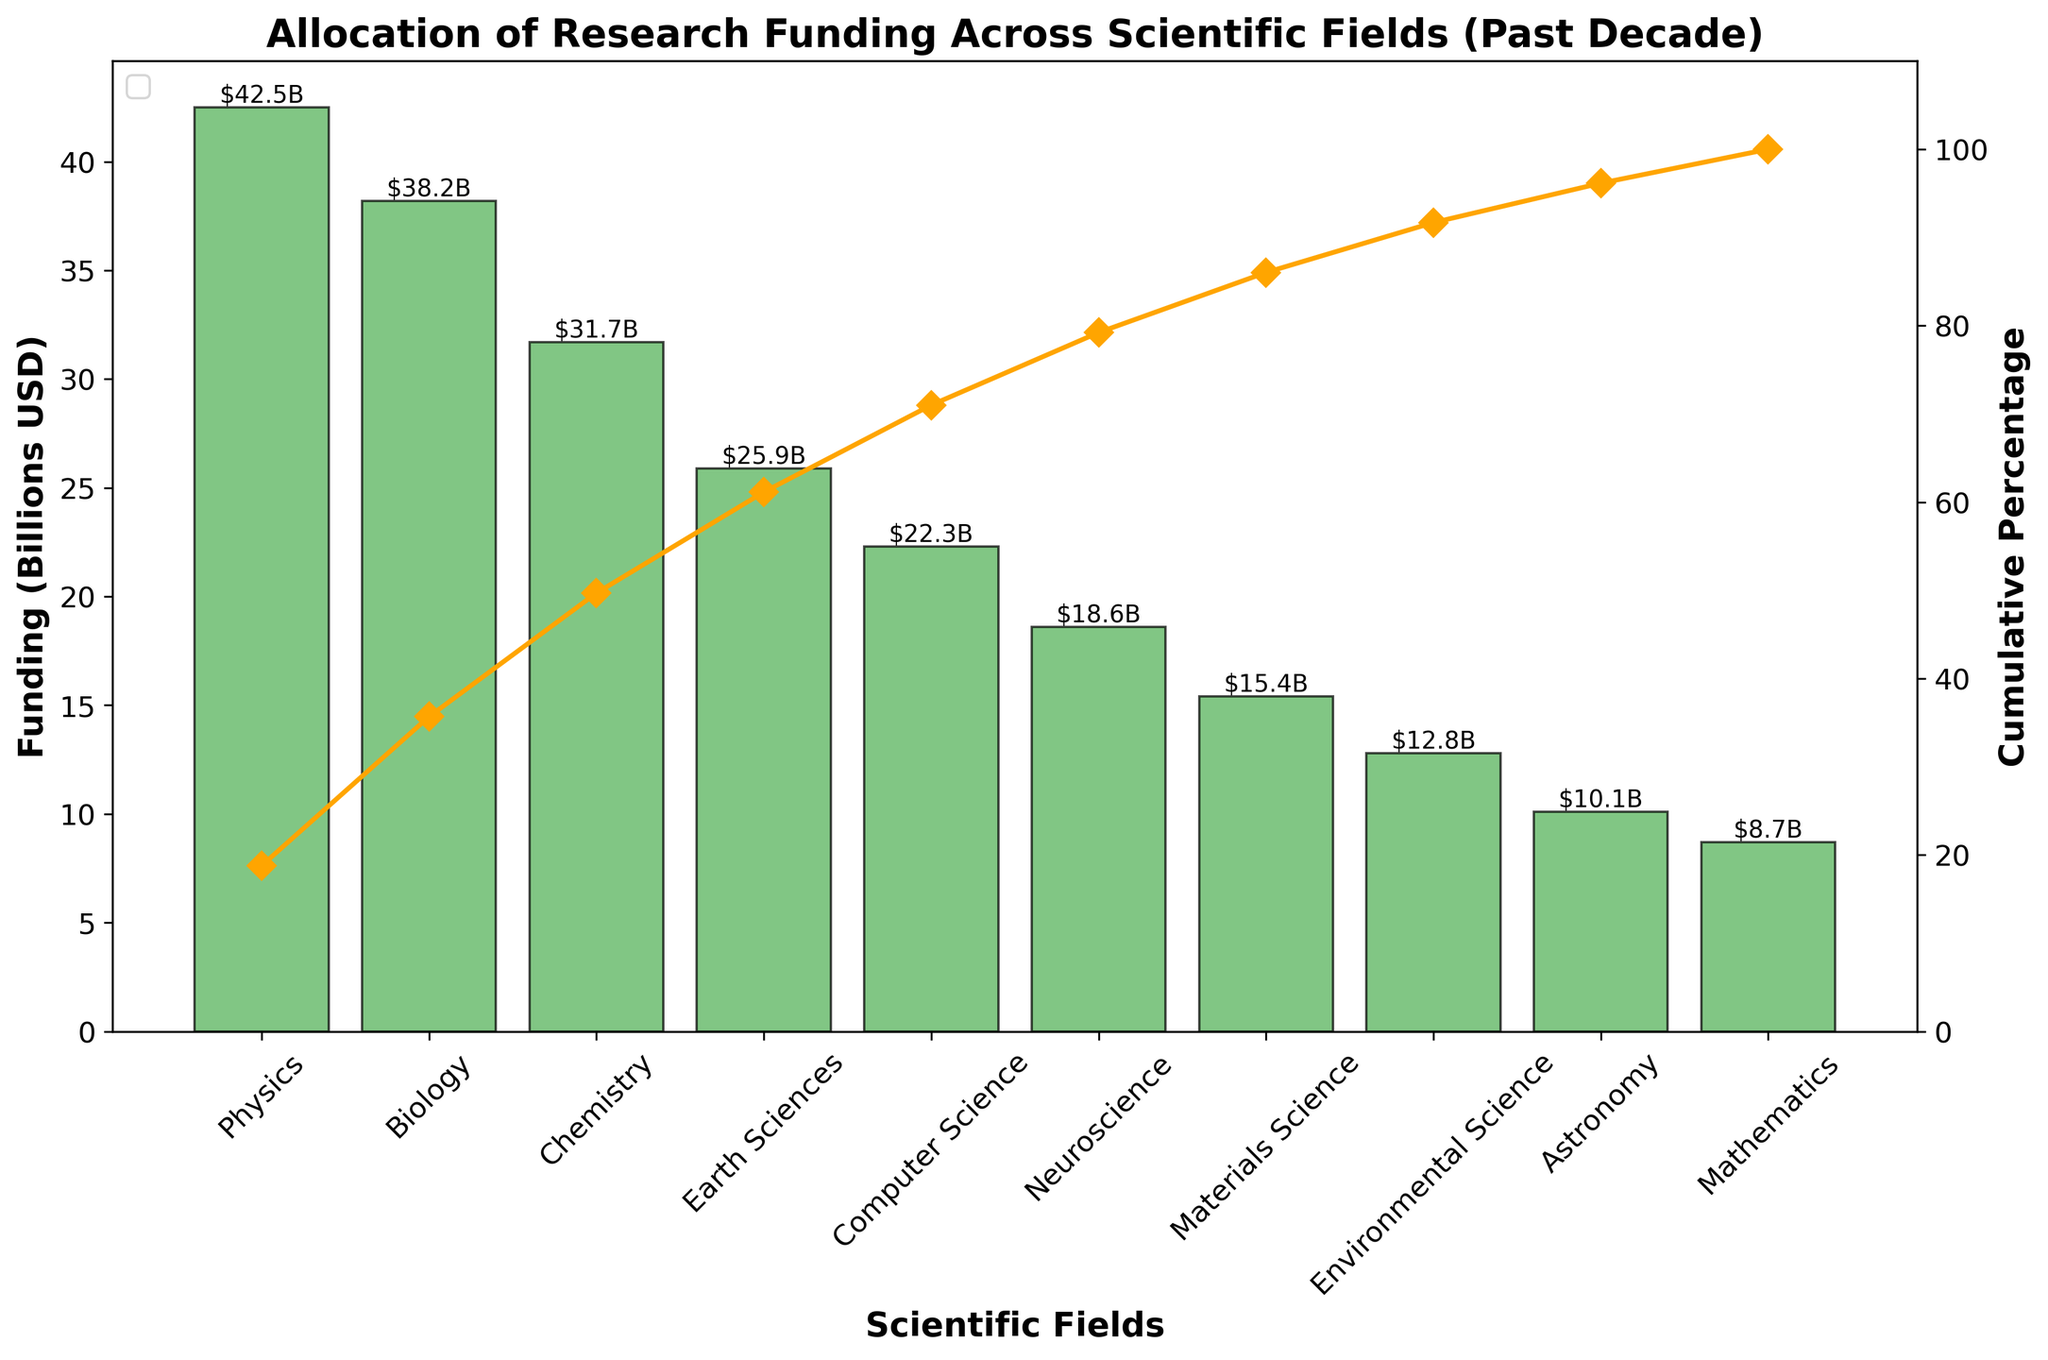What is the title of the figure? The title of the figure is generally placed at the top of the chart and it describes the overall content. According to the details, we can infer the title.
Answer: Allocation of Research Funding Across Scientific Fields (Past Decade) How many scientific fields are analyzed in the figure? The number of scientific fields can be determined by counting the bars in the bar plot.
Answer: 10 Which scientific field received the highest amount of funding? The bar with the greatest height represents the scientific field with the highest funding.
Answer: Physics What is the cumulative percentage for the field of Biology? The cumulative percentage for Biology can be read from the point on the secondary y-axis corresponding to Biology on the x-axis.
Answer: 48.5% What is the funding amount for Mathematics? The height of the bar corresponding to Mathematics indicates its funding amount.
Answer: 8.7 Billion USD Which fields combined make up 80% of the total funding? To find this, refer to the cumulative percentage line. The fields contributing to 80% can be found by moving along the line until reaching 80%.
Answer: Physics, Biology, Chemistry, and Earth Sciences How much more funding did Physics receive compared to Environmental Science? Find the heights of the bars for both Physics and Environmental Science and calculate their difference. Physics: 42.5 Billion USD, Environmental Science: 12.8 Billion USD. Hence, 42.5 - 12.8 = 29.7 Billion USD.
Answer: 29.7 Billion USD What percentage of the total funding does Computer Science account for? The percentage can be calculated by dividing the funding amount for Computer Science by the total funding and multiplying by 100. Total funding is the sum of all individual funding amounts. Total: 225.2 Billion USD, Computer Science: 22.3 Billion USD. Hence, (22.3 / 225.2) * 100 ≈ 9.9%.
Answer: 9.9% Which field contributes more to the total funding, Astronomy or Materials Science, and by how much? Compare the heights of the bars for Astronomy and Materials Science to determine which one is higher and calculate their difference. Materials Science: 15.4 Billion USD, Astronomy: 10.1 Billion USD. Hence, 15.4 - 10.1 = 5.3 Billion USD.
Answer: Materials Science by 5.3 Billion USD What is the average funding for the fields represented in the figure? Sum all the funding amounts and divide by the number of fields. Sum: 42.5 + 38.2 + 31.7 + 25.9 + 22.3 + 18.6 + 15.4 + 12.8 + 10.1 + 8.7 = 225.2 Billion USD. Average: 225.2 / 10 = 22.52 Billion USD.
Answer: 22.52 Billion USD 